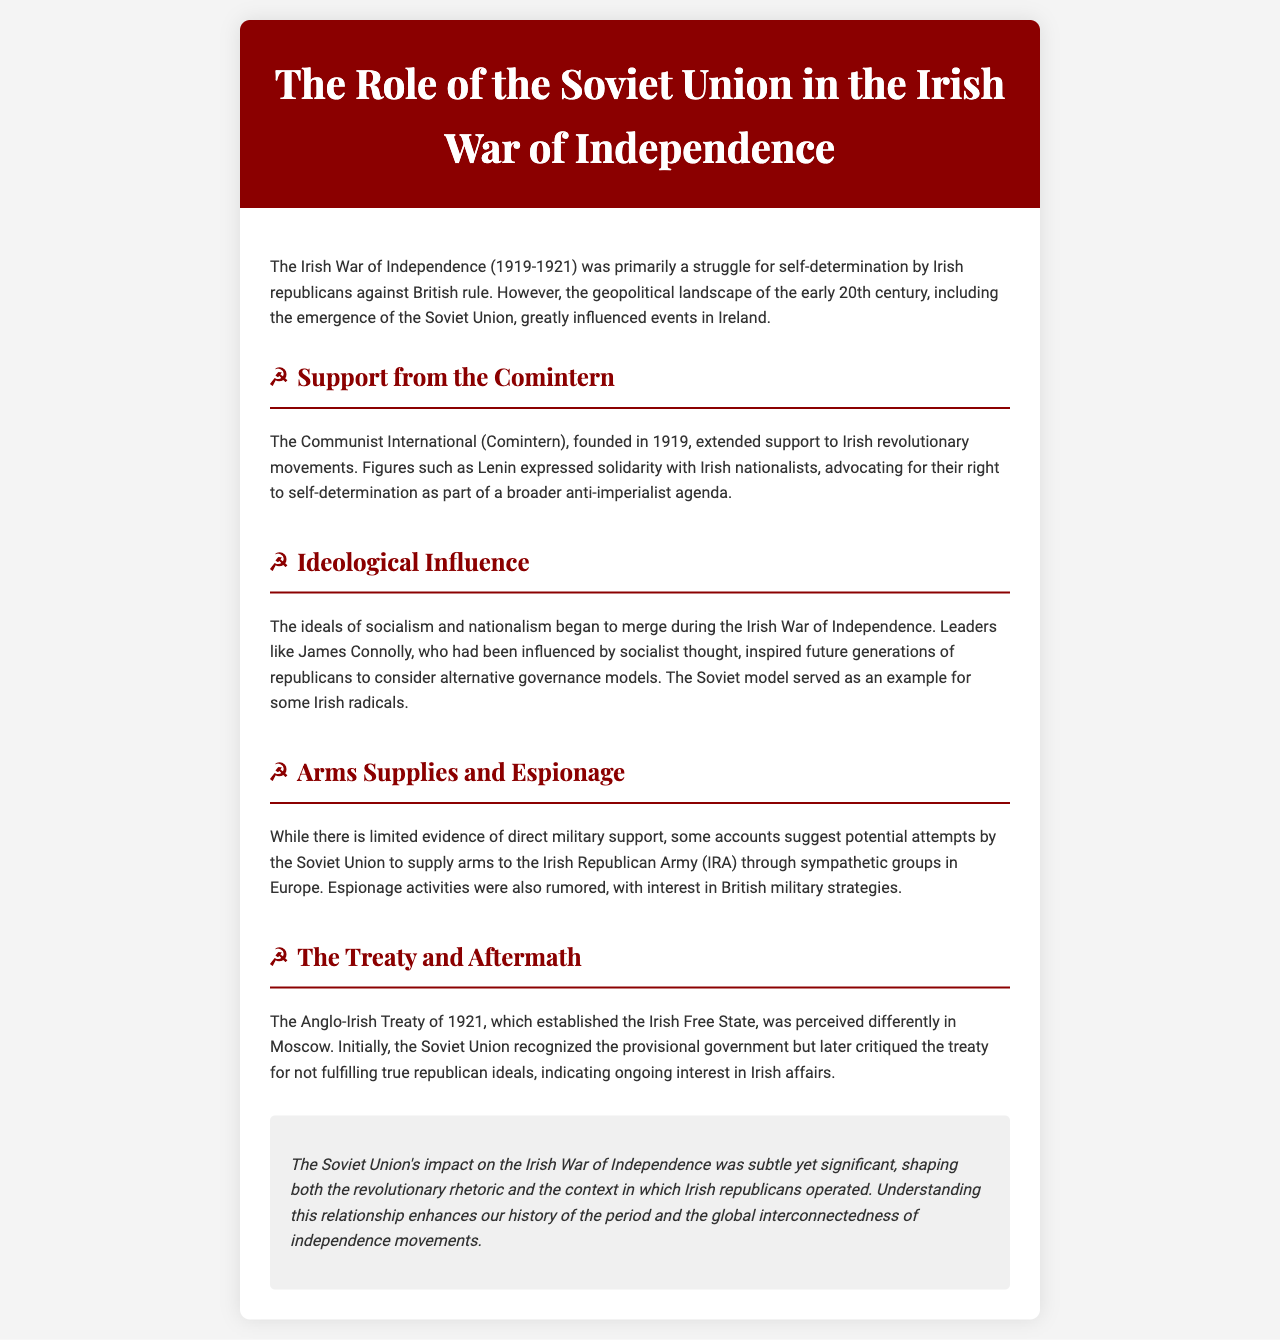What was the time period of the Irish War of Independence? The document states that the Irish War of Independence occurred from 1919 to 1921.
Answer: 1919-1921 Who expressed solidarity with Irish nationalists? The document mentions figures such as Lenin expressed solidarity with Irish nationalists.
Answer: Lenin What organization extended support to Irish revolutionary movements? The document states that the Communist International (Comintern) extended support.
Answer: Communist International (Comintern) Which leader was influenced by socialist thought? The document identifies James Connolly as a leader influenced by socialist thought.
Answer: James Connolly What was critiqued by the Soviet Union after the Anglo-Irish Treaty? The document indicates that the treaty was critiqued for not fulfilling true republican ideals.
Answer: True republican ideals What was the perception of the Soviet Union towards the Anglo-Irish Treaty initially? The document notes that the Soviet Union initially recognized the provisional government.
Answer: Recognized the provisional government What type of activities were rumored involving the Soviet Union? The document mentions espionage activities were rumored regarding British military strategies.
Answer: Espionage activities What is the overall impact of the Soviet Union on the Irish War of Independence described as? The document describes the impact as subtle yet significant in shaping revolutionary rhetoric.
Answer: Subtle yet significant 